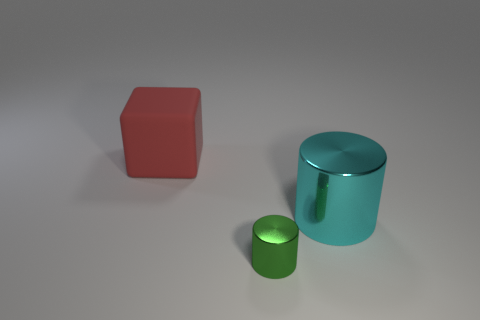What is the color of the metal cylinder in front of the thing on the right side of the green metal thing?
Ensure brevity in your answer.  Green. Are the cube and the cylinder that is in front of the cyan shiny thing made of the same material?
Provide a succinct answer. No. What material is the cylinder that is to the right of the tiny green metallic cylinder?
Your answer should be compact. Metal. Are there the same number of objects that are behind the small thing and brown spheres?
Offer a terse response. No. Is there any other thing that is the same size as the red matte cube?
Ensure brevity in your answer.  Yes. There is a cylinder left of the large thing that is in front of the red thing; what is it made of?
Provide a short and direct response. Metal. The object that is in front of the big red rubber block and behind the green cylinder has what shape?
Your response must be concise. Cylinder. What is the size of the other metallic object that is the same shape as the small thing?
Your answer should be compact. Large. Are there fewer small green cylinders to the right of the cyan metal cylinder than big blue matte things?
Offer a terse response. No. There is a metal thing that is behind the green cylinder; what is its size?
Keep it short and to the point. Large. 